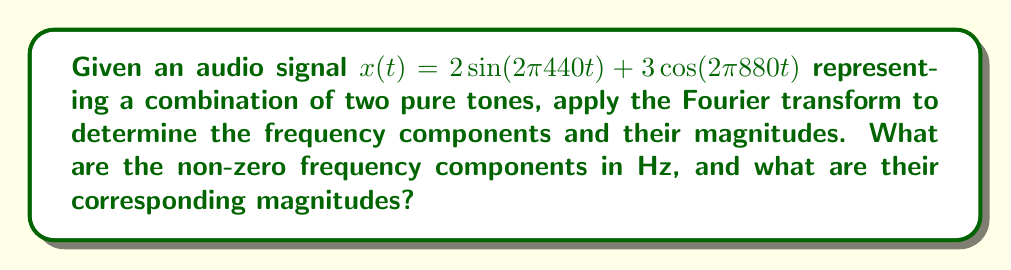Give your solution to this math problem. Let's approach this step-by-step:

1) The Fourier transform of a signal $x(t)$ is given by:

   $$X(f) = \int_{-\infty}^{\infty} x(t) e^{-j2\pi ft} dt$$

2) We need to apply this to our signal:
   
   $x(t) = 2\sin(2\pi 440t) + 3\cos(2\pi 880t)$

3) First, let's recall some trigonometric identities:
   
   $\sin(A) = \frac{e^{jA} - e^{-jA}}{2j}$
   $\cos(A) = \frac{e^{jA} + e^{-jA}}{2}$

4) Applying these to our signal:

   $x(t) = 2\left(\frac{e^{j2\pi 440t} - e^{-j2\pi 440t}}{2j}\right) + 3\left(\frac{e^{j2\pi 880t} + e^{-j2\pi 880t}}{2}\right)$

5) Simplifying:

   $x(t) = j(e^{-j2\pi 440t} - e^{j2\pi 440t}) + \frac{3}{2}(e^{j2\pi 880t} + e^{-j2\pi 880t})$

6) Now, we can use the linearity property of the Fourier transform and the fact that:

   $\mathcal{F}\{e^{j2\pi f_0t}\} = \delta(f - f_0)$

   where $\delta$ is the Dirac delta function.

7) Applying the Fourier transform to each term:

   $X(f) = j\delta(f + 440) - j\delta(f - 440) + \frac{3}{2}\delta(f - 880) + \frac{3}{2}\delta(f + 880)$

8) The magnitude of the Fourier transform is:

   $|X(f)| = |\pm j|\delta(f \pm 440) + \frac{3}{2}\delta(f \pm 880)$
           $= \delta(f \pm 440) + \frac{3}{2}\delta(f \pm 880)$

9) Therefore, the non-zero frequency components are at ±440 Hz and ±880 Hz.
   The magnitudes are 1 for ±440 Hz and 1.5 for ±880 Hz.
Answer: ±440 Hz with magnitude 1, ±880 Hz with magnitude 1.5 